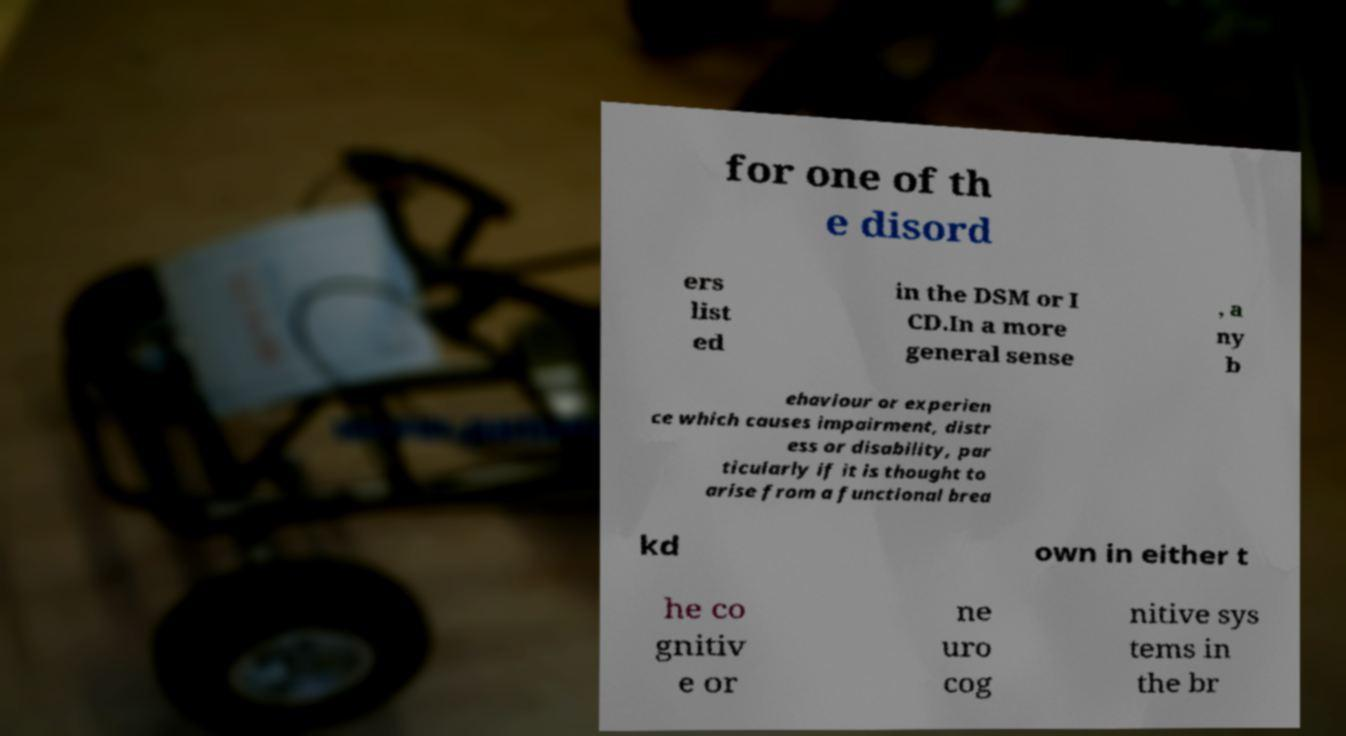Could you extract and type out the text from this image? for one of th e disord ers list ed in the DSM or I CD.In a more general sense , a ny b ehaviour or experien ce which causes impairment, distr ess or disability, par ticularly if it is thought to arise from a functional brea kd own in either t he co gnitiv e or ne uro cog nitive sys tems in the br 